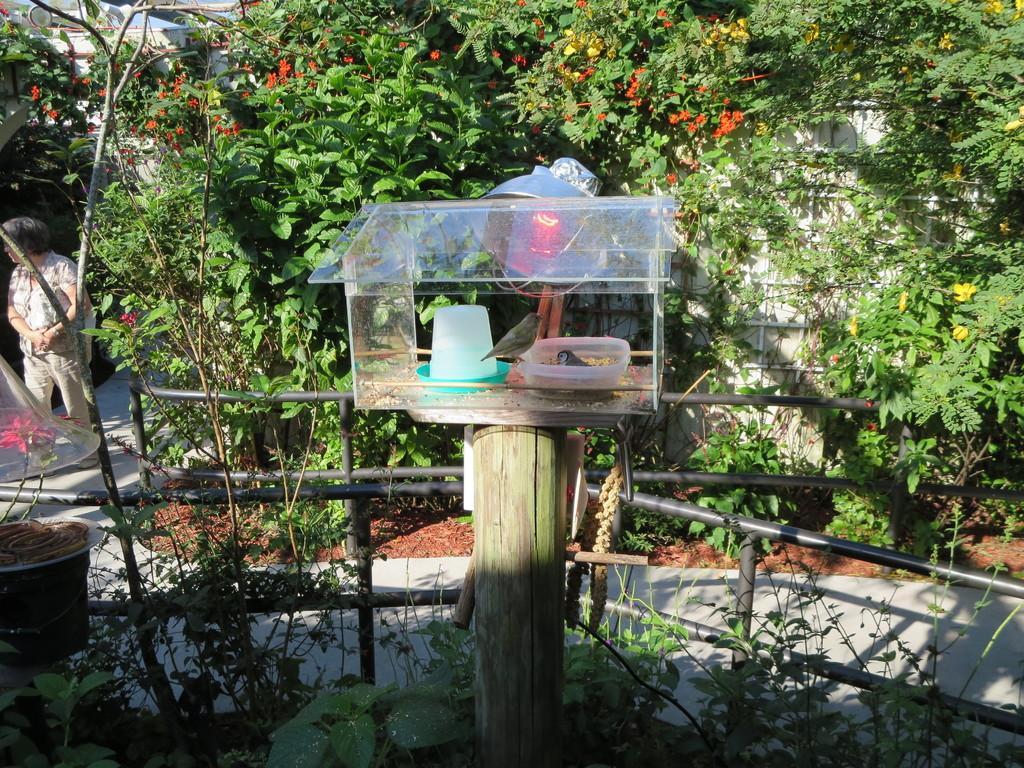Please provide a concise description of this image. In the picture we can see bird's cage which is made of glass and there are two birds in it and there is bird feed and in the background of the picture there is woman standing and there are some plants, trees and there is walkway. 